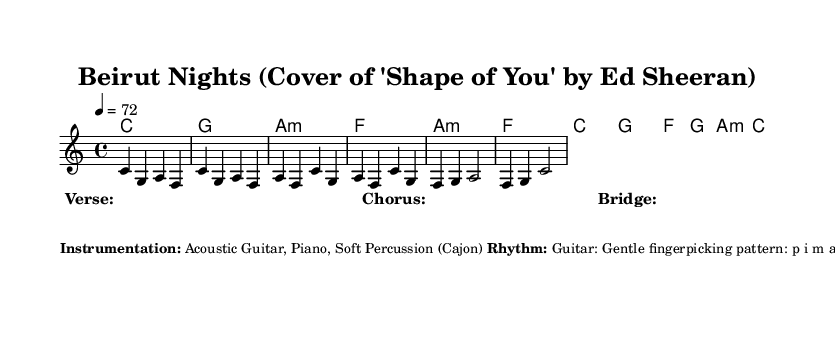What is the key signature of this music? The key signature is indicated at the beginning of the score and shows that it is in C major, which has no sharps or flats.
Answer: C major What is the time signature for this piece? The time signature is also marked at the beginning of the score, indicating a standard 4/4 time signature, which means there are four beats in each measure.
Answer: 4/4 What is the tempo marking for the music? The tempo is specified in the score as "4 = 72," meaning that the quarter note should be played at 72 beats per minute, which gives a sense of the song's pace.
Answer: 72 How many measures are in the verse section? By examining the melody section that corresponds to the verse, we can count the measures, which total four measures in this case.
Answer: 4 What style of rhythm is indicated for the guitar? The score provides details in the markup section, stating that the guitar uses a gentle fingerpicking pattern, which defines the rhythmic style for the instrument.
Answer: Gentle fingerpicking What dynamics are indicated for the piece? The dynamics information in the markup mentions that the music should generally be soft and mellow, with a slight crescendo in the chorus. This indicates the overall volume and expression intended.
Answer: Soft and mellow What unique embellishments are suggested in the music? The additional notes section of the markup indicates that occasional Lebanese oud-inspired embellishments should be added between phrases, highlighting the cultural influence in the arrangement.
Answer: Oud-inspired embellishments 